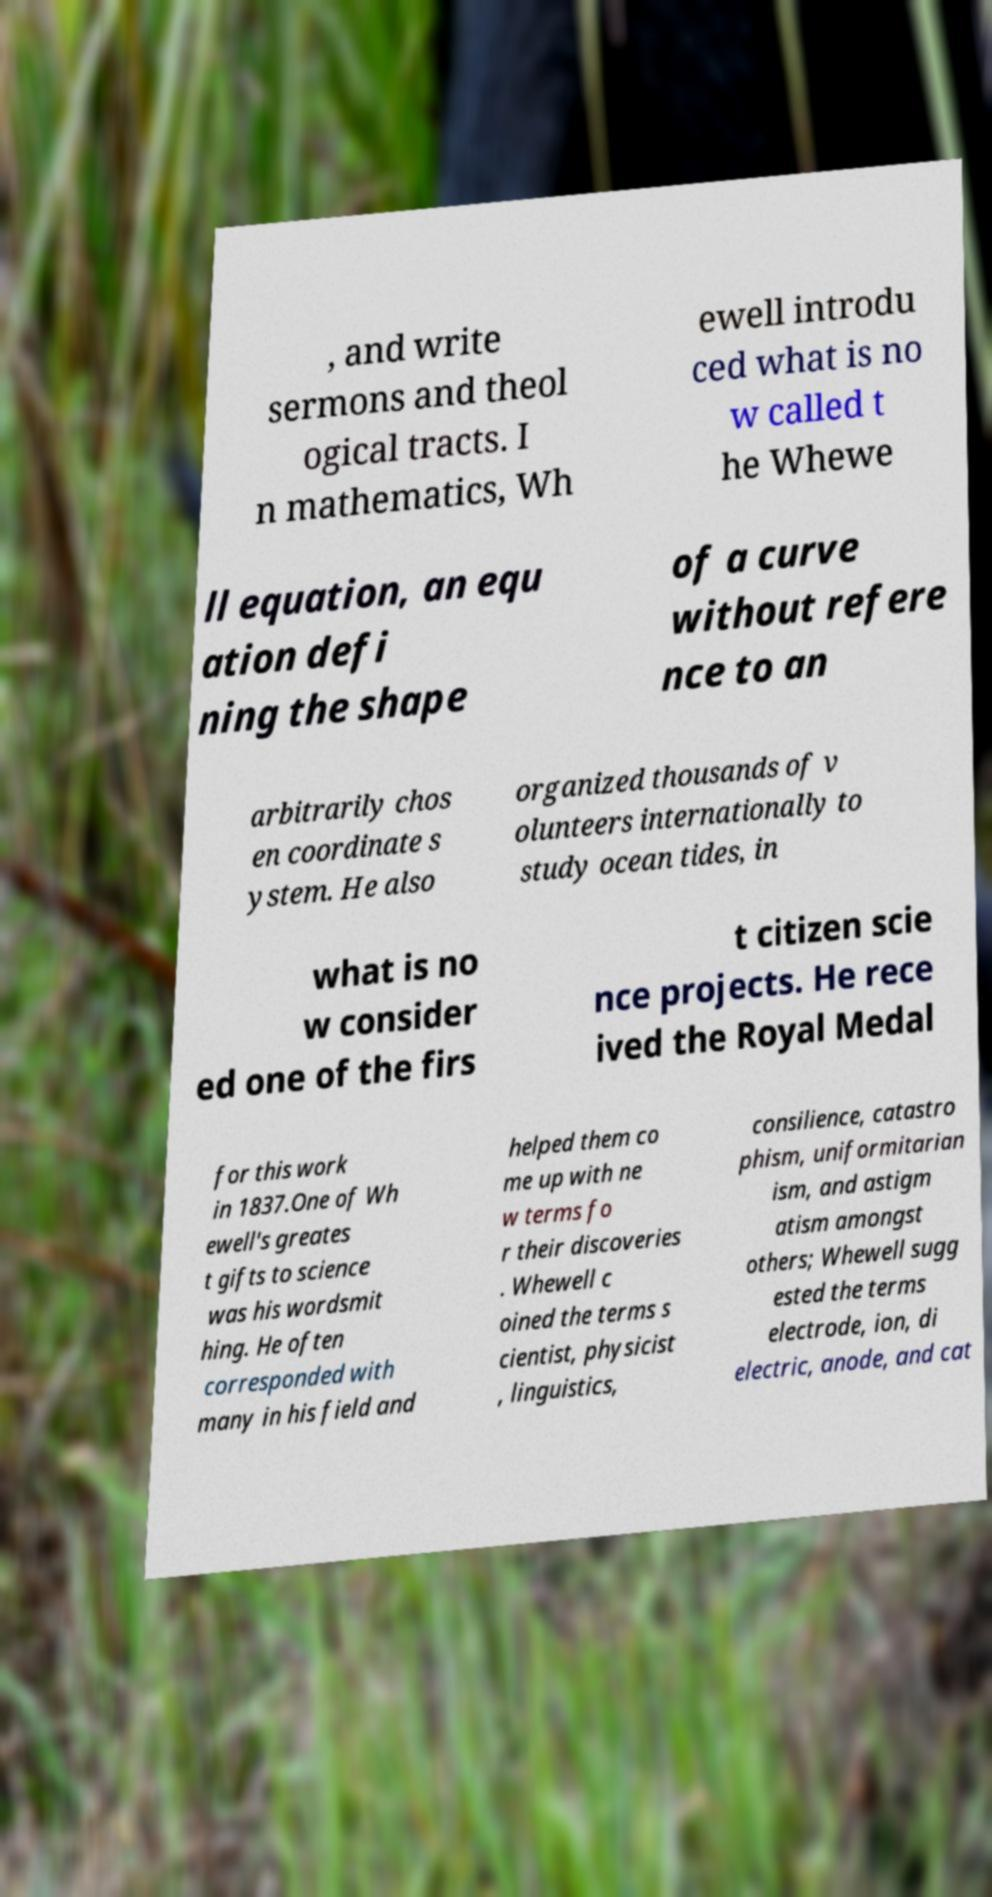Can you read and provide the text displayed in the image?This photo seems to have some interesting text. Can you extract and type it out for me? , and write sermons and theol ogical tracts. I n mathematics, Wh ewell introdu ced what is no w called t he Whewe ll equation, an equ ation defi ning the shape of a curve without refere nce to an arbitrarily chos en coordinate s ystem. He also organized thousands of v olunteers internationally to study ocean tides, in what is no w consider ed one of the firs t citizen scie nce projects. He rece ived the Royal Medal for this work in 1837.One of Wh ewell's greates t gifts to science was his wordsmit hing. He often corresponded with many in his field and helped them co me up with ne w terms fo r their discoveries . Whewell c oined the terms s cientist, physicist , linguistics, consilience, catastro phism, uniformitarian ism, and astigm atism amongst others; Whewell sugg ested the terms electrode, ion, di electric, anode, and cat 